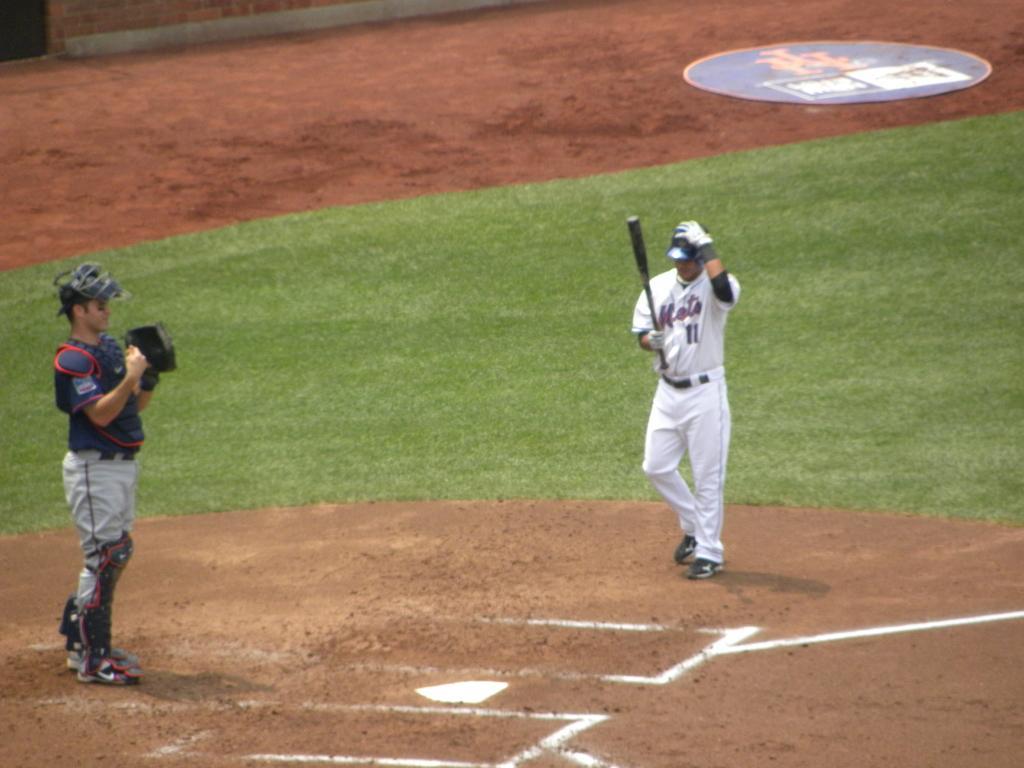How would you summarize this image in a sentence or two? In this image there are two persons standing on the ground, a person holding a baseball bat , and in the background there is a board on the ground. 